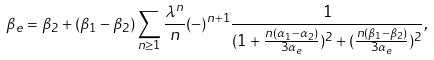Convert formula to latex. <formula><loc_0><loc_0><loc_500><loc_500>\beta _ { e } = \beta _ { 2 } + ( \beta _ { 1 } - \beta _ { 2 } ) \sum _ { n \geq 1 } \frac { \lambda ^ { n } } { n } ( - ) ^ { n + 1 } \frac { 1 } { ( 1 + \frac { n ( \alpha _ { 1 } - \alpha _ { 2 } ) } { 3 \alpha _ { e } } ) ^ { 2 } + ( \frac { n ( \beta _ { 1 } - \beta _ { 2 } ) } { 3 \alpha _ { e } } ) ^ { 2 } } ,</formula> 